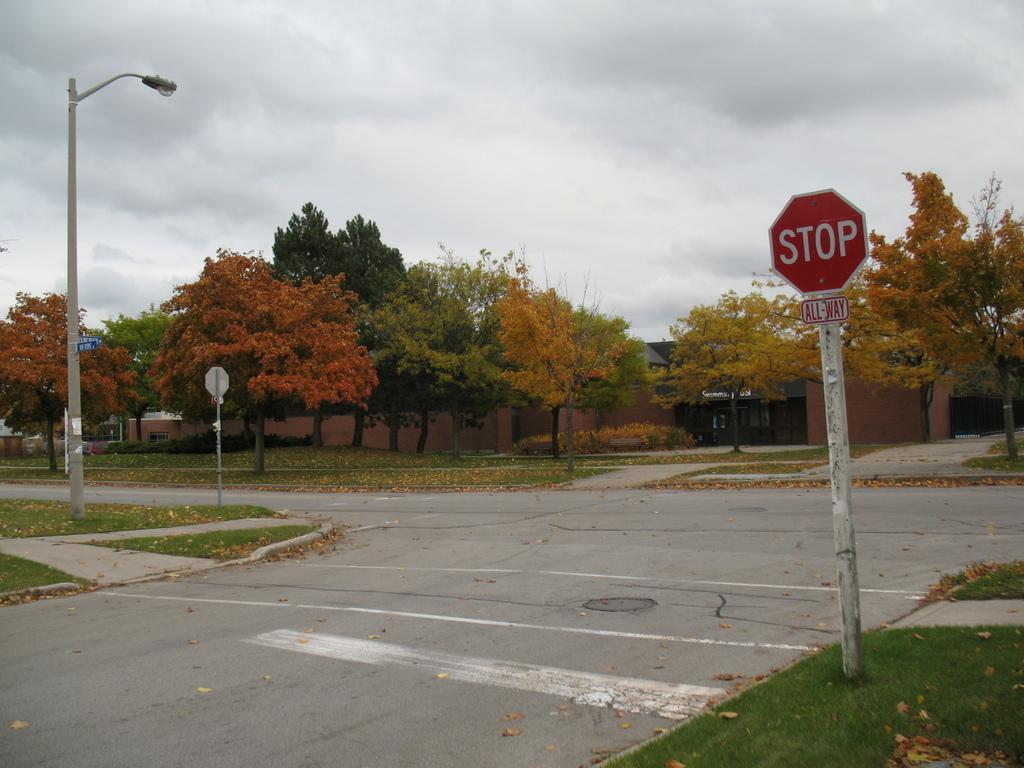What type of pathway can be seen in the image? There is a road in the image. What type of vegetation is present in the image? Trees are present in the image. What type of structures can be seen in the image? Buildings are visible in the image. What type of ground cover is present in the image? Grass is present in the image. What type of signage is present in the image? Boards are attached to poles in the image. Where is the street light located in the image? The street light is on the left side of the image. What can be seen in the background of the image? The sky is visible in the background of the image. What type of advice can be seen written on the boards in the image? There is no advice written on the boards in the image; they are attached to poles without any text or images. What type of vehicle is driving down the road in the image? There is no vehicle present in the image; it only shows a road, trees, buildings, grass, boards, a street light, and the sky. 